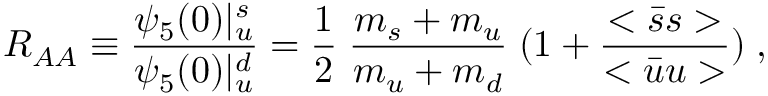<formula> <loc_0><loc_0><loc_500><loc_500>R _ { A A } \equiv \frac { \psi _ { 5 } ( 0 ) | _ { u } ^ { s } } { \psi _ { 5 } ( 0 ) | _ { u } ^ { d } } = \frac { 1 } { 2 } \, \frac { m _ { s } + m _ { u } } { m _ { u } + m _ { d } } \, ( 1 + \frac { < \bar { s } s > } { < \bar { u } u > } ) \, ,</formula> 